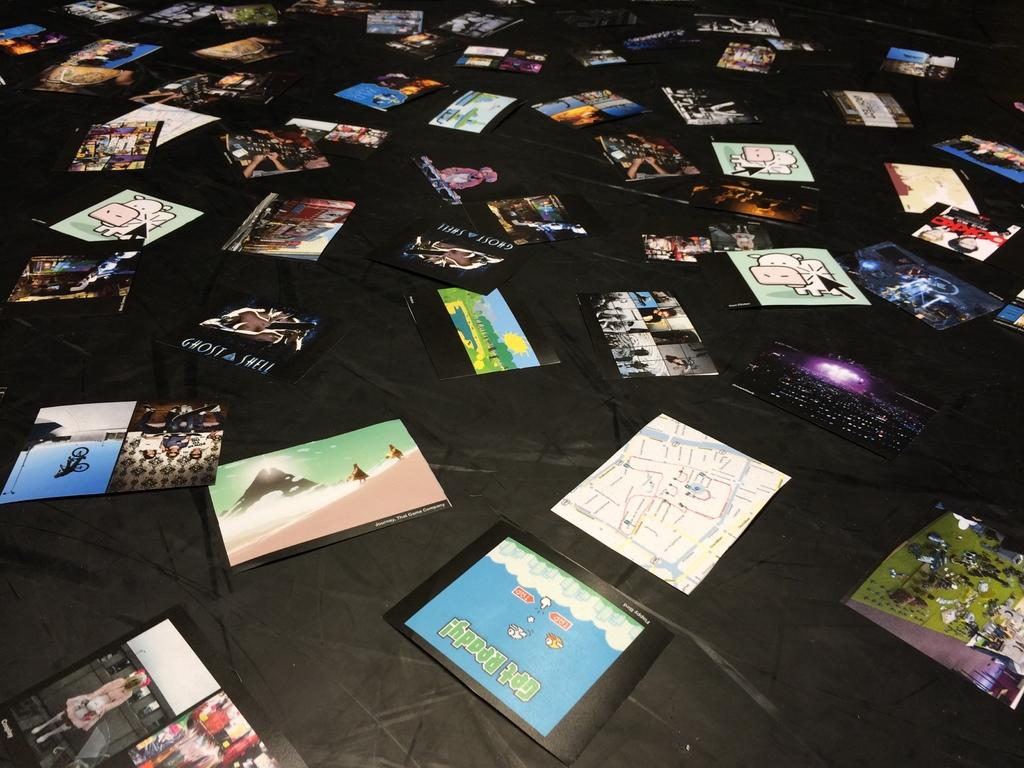What can be seen in the image? There are photos in the image. How are the photos arranged or displayed? The photos are placed on a black cloth. Can you observe the playground in the image? There is no playground present in the image; it only contains photos placed on a black cloth. 